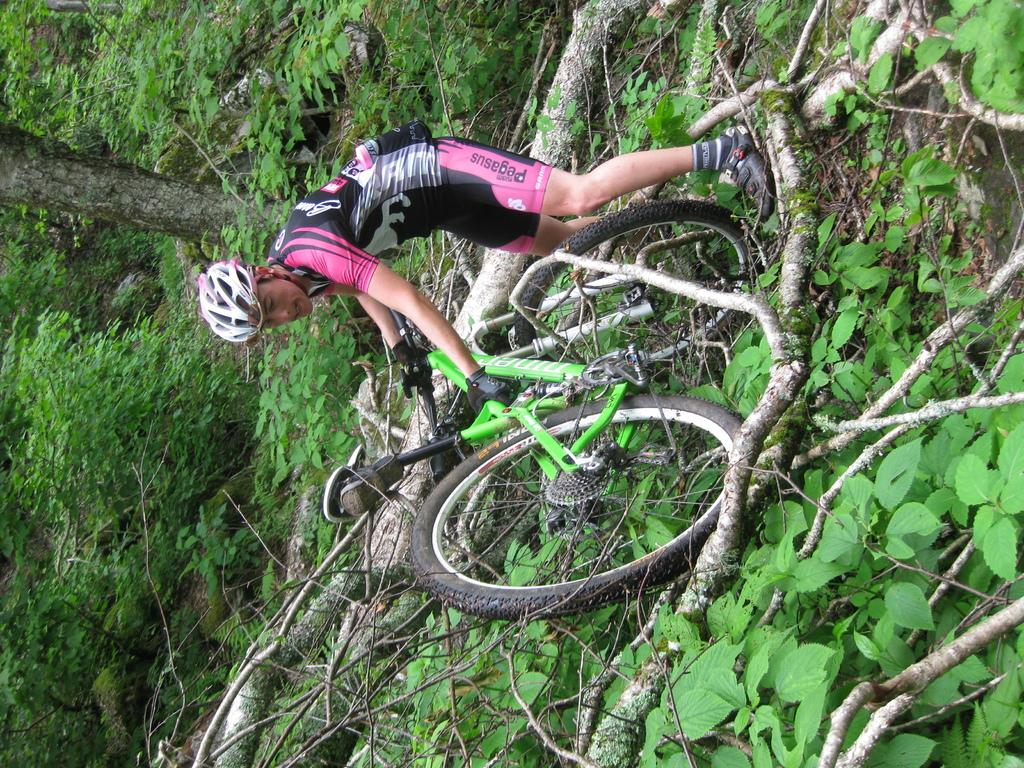What is the person in the image doing? The person is standing in the image. What protective gear is the person wearing? The person is wearing a helmet. What object is the person holding? The person is holding a green bicycle. What obstacle can be seen on the ground in the image? There is a fallen tree on the ground. What type of vegetation is visible in the background of the image? There are trees visible in the background of the image. What type of vegetable is being used as a prop in the image? There is no vegetable present in the image; it features a person standing with a helmet and a green bicycle, along with a fallen tree and trees in the background. 